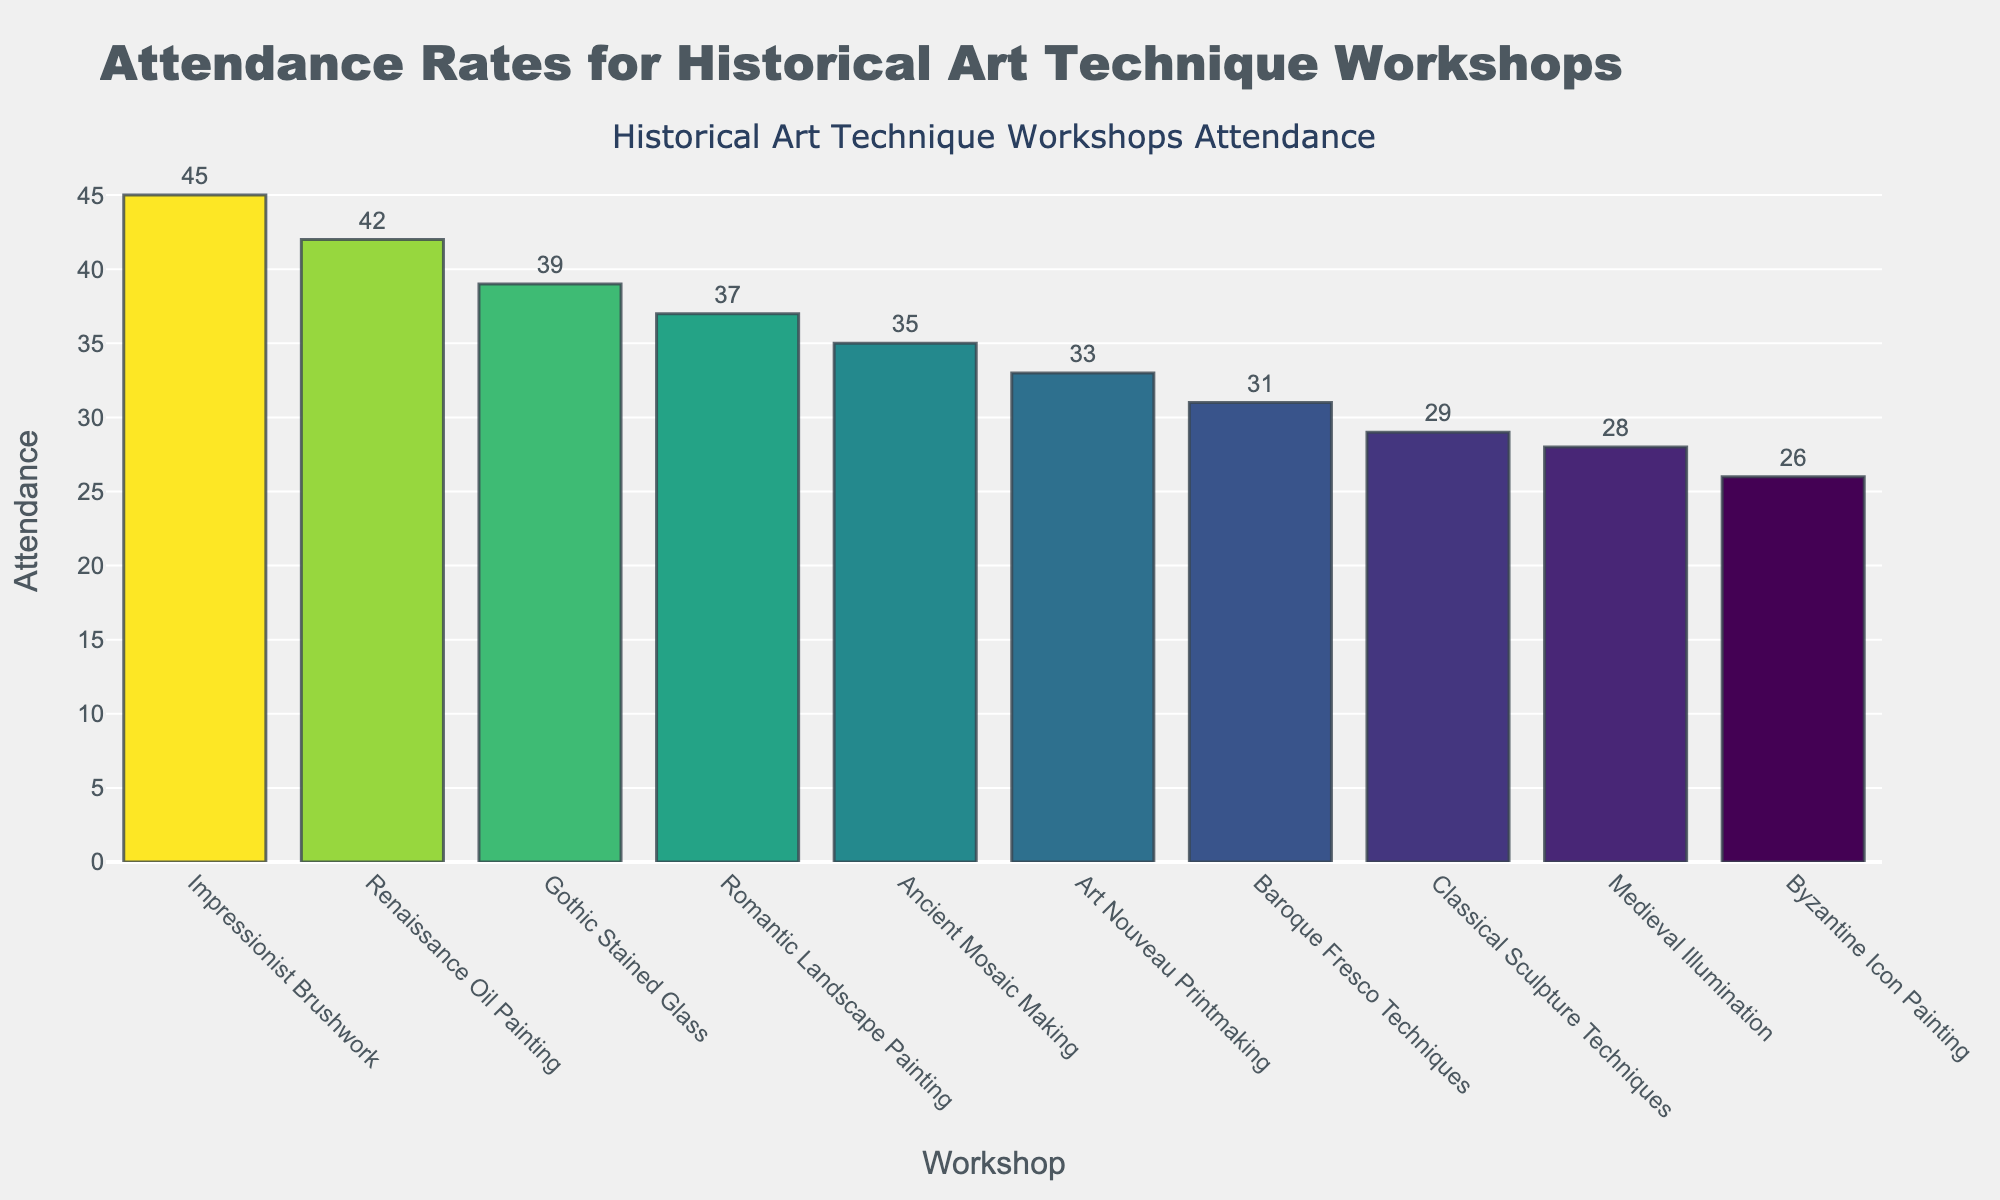What's the attendance for the Impressionist Brushwork workshop? The bar for the Impressionist Brushwork workshop shows that the attendance rate is 45.
Answer: 45 Which workshop had the lowest attendance? The bar for the Byzantine Icon Painting workshop is the shortest, indicating that it had the lowest attendance at 26.
Answer: Byzantine Icon Painting What is the difference in attendance between the Renaissance Oil Painting and Classical Sculpture Techniques workshops? The attendance for the Renaissance Oil Painting workshop is 42, and for Classical Sculpture Techniques, it is 29. The difference is 42 - 29 = 13.
Answer: 13 Which workshop received higher attendance: Ancient Mosaic Making or Baroque Fresco Techniques? The bar for Ancient Mosaic Making is higher than the one for Baroque Fresco Techniques, indicating higher attendance. The attendance for Ancient Mosaic Making is 35, and Baroque Fresco Techniques is 31.
Answer: Ancient Mosaic Making What's the total attendance for Medieval Illumination, Gothic Stained Glass, and Romantic Landscape Painting workshops combined? The attendance for Medieval Illumination is 28, for Gothic Stained Glass is 39, and for Romantic Landscape Painting is 37. Their total is 28 + 39 + 37 = 104.
Answer: 104 Identify the workshop with the median attendance rate. To find the median, list all attendances in ascending order: 26, 28, 29, 31, 33, 35, 37, 39, 42, 45. The median falls between the fifth and sixth values (33 and 35). Since the average of 33 and 35 is 34, which doesn't exactly match any workshop, the median attendance of 34 should be approximated back to the values 33 and 35. The workshop for these values is Art Nouveau Printmaking and Ancient Mosaic Making respectively.
Answer: Art Nouveau Printmaking and Ancient Mosaic Making Which workshop had the second highest attendance, and what was it? The second tallest bar, representing the workshop with the second highest attendance, is the Renaissance Oil Painting workshop with an attendance of 42.
Answer: Renaissance Oil Painting, 42 How many workshops had an attendance greater than 30? The bars for Renaissance Oil Painting (42), Ancient Mosaic Making (35), Baroque Fresco Techniques (31), Gothic Stained Glass (39), Impressionist Brushwork (45), Romantic Landscape Painting (37), and Art Nouveau Printmaking (33) all exceed 30. Counting these bars, there are 7 workshops.
Answer: 7 Which workshops' attendance values fall within the range of 25 to 35? Sorting through the bars within the specified range, the workshops are: Ancient Mosaic Making (35), Medieval Illumination (28), Classical Sculpture Techniques (29), Baroque Fresco Techniques (31), and Byzantine Icon Painting (26).
Answer: Ancient Mosaic Making, Medieval Illumination, Classical Sculpture Techniques, Baroque Fresco Techniques, Byzantine Icon Painting 